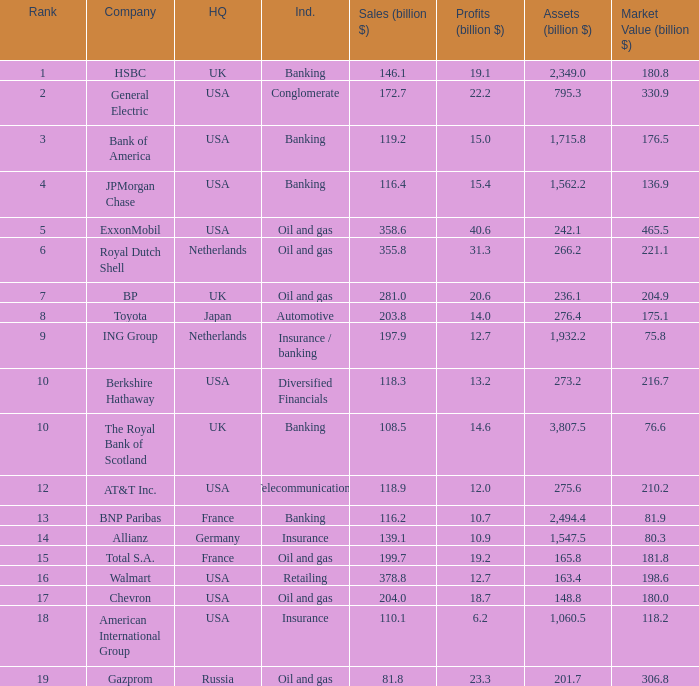What is the highest rank of a company that has 1,715.8 billion in assets?  3.0. 